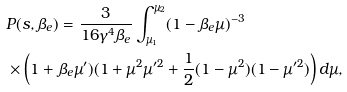Convert formula to latex. <formula><loc_0><loc_0><loc_500><loc_500>& P ( s , \beta _ { e } ) = \frac { 3 } { 1 6 \gamma ^ { 4 } \beta _ { e } } \int _ { \mu _ { 1 } } ^ { \mu _ { 2 } } ( 1 - \beta _ { e } \mu ) ^ { - 3 } \\ & \times \left ( 1 + \beta _ { e } \mu ^ { \prime } ) ( 1 + \mu ^ { 2 } \mu ^ { \prime 2 } + \frac { 1 } { 2 } ( 1 - \mu ^ { 2 } ) ( 1 - \mu ^ { \prime 2 } ) \right ) d \mu ,</formula> 